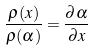<formula> <loc_0><loc_0><loc_500><loc_500>\frac { \rho ( x ) } { \rho ( \alpha ) } = \frac { \partial \alpha } { \partial x }</formula> 